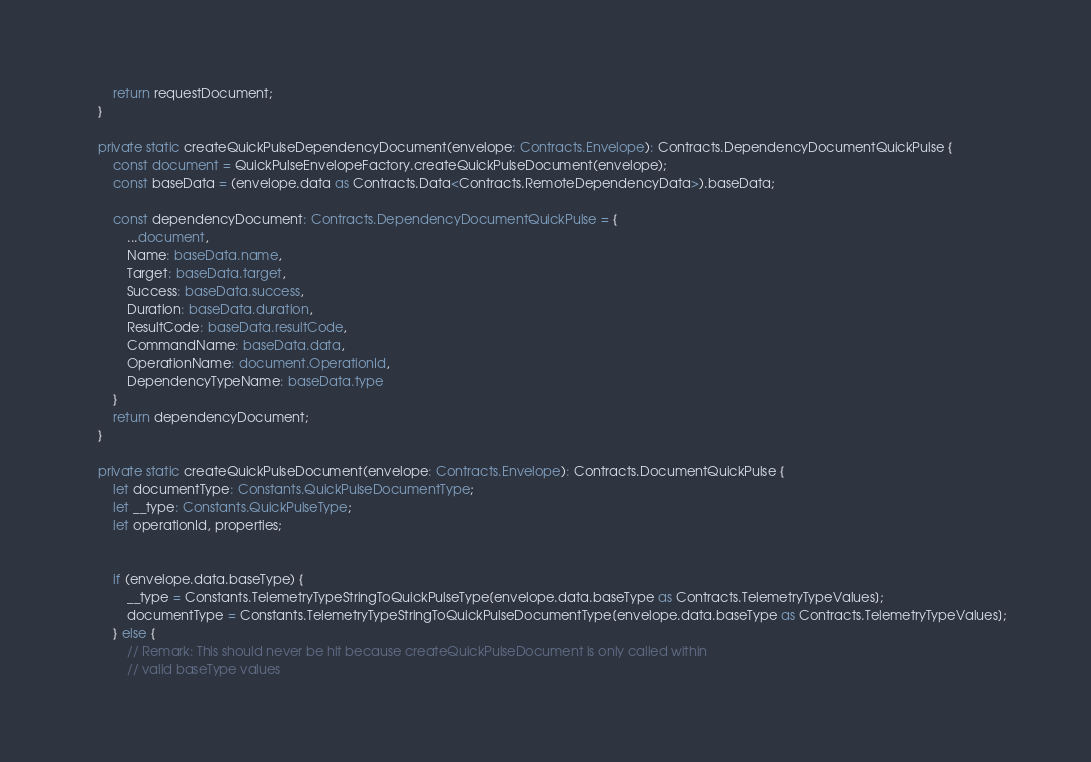Convert code to text. <code><loc_0><loc_0><loc_500><loc_500><_TypeScript_>        return requestDocument;
    }

    private static createQuickPulseDependencyDocument(envelope: Contracts.Envelope): Contracts.DependencyDocumentQuickPulse {
        const document = QuickPulseEnvelopeFactory.createQuickPulseDocument(envelope);
        const baseData = (envelope.data as Contracts.Data<Contracts.RemoteDependencyData>).baseData;

        const dependencyDocument: Contracts.DependencyDocumentQuickPulse = {
            ...document,
            Name: baseData.name,
            Target: baseData.target,
            Success: baseData.success,
            Duration: baseData.duration,
            ResultCode: baseData.resultCode,
            CommandName: baseData.data,
            OperationName: document.OperationId,
            DependencyTypeName: baseData.type
        }
        return dependencyDocument;
    }

    private static createQuickPulseDocument(envelope: Contracts.Envelope): Contracts.DocumentQuickPulse {
        let documentType: Constants.QuickPulseDocumentType;
        let __type: Constants.QuickPulseType;
        let operationId, properties;


        if (envelope.data.baseType) {
            __type = Constants.TelemetryTypeStringToQuickPulseType[envelope.data.baseType as Contracts.TelemetryTypeValues];
            documentType = Constants.TelemetryTypeStringToQuickPulseDocumentType[envelope.data.baseType as Contracts.TelemetryTypeValues];
        } else {
            // Remark: This should never be hit because createQuickPulseDocument is only called within
            // valid baseType values</code> 